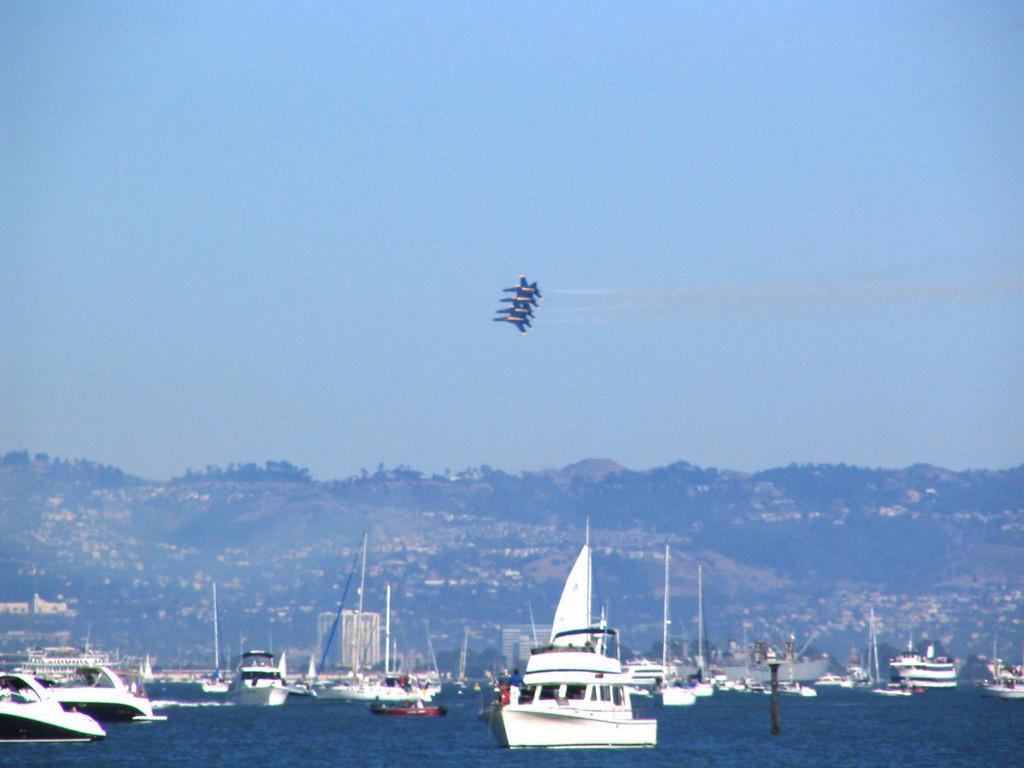In one or two sentences, can you explain what this image depicts? In this image, there are a few ships sailing on the water. We can also see some buildings, hills and airways. We can also see the sky. 